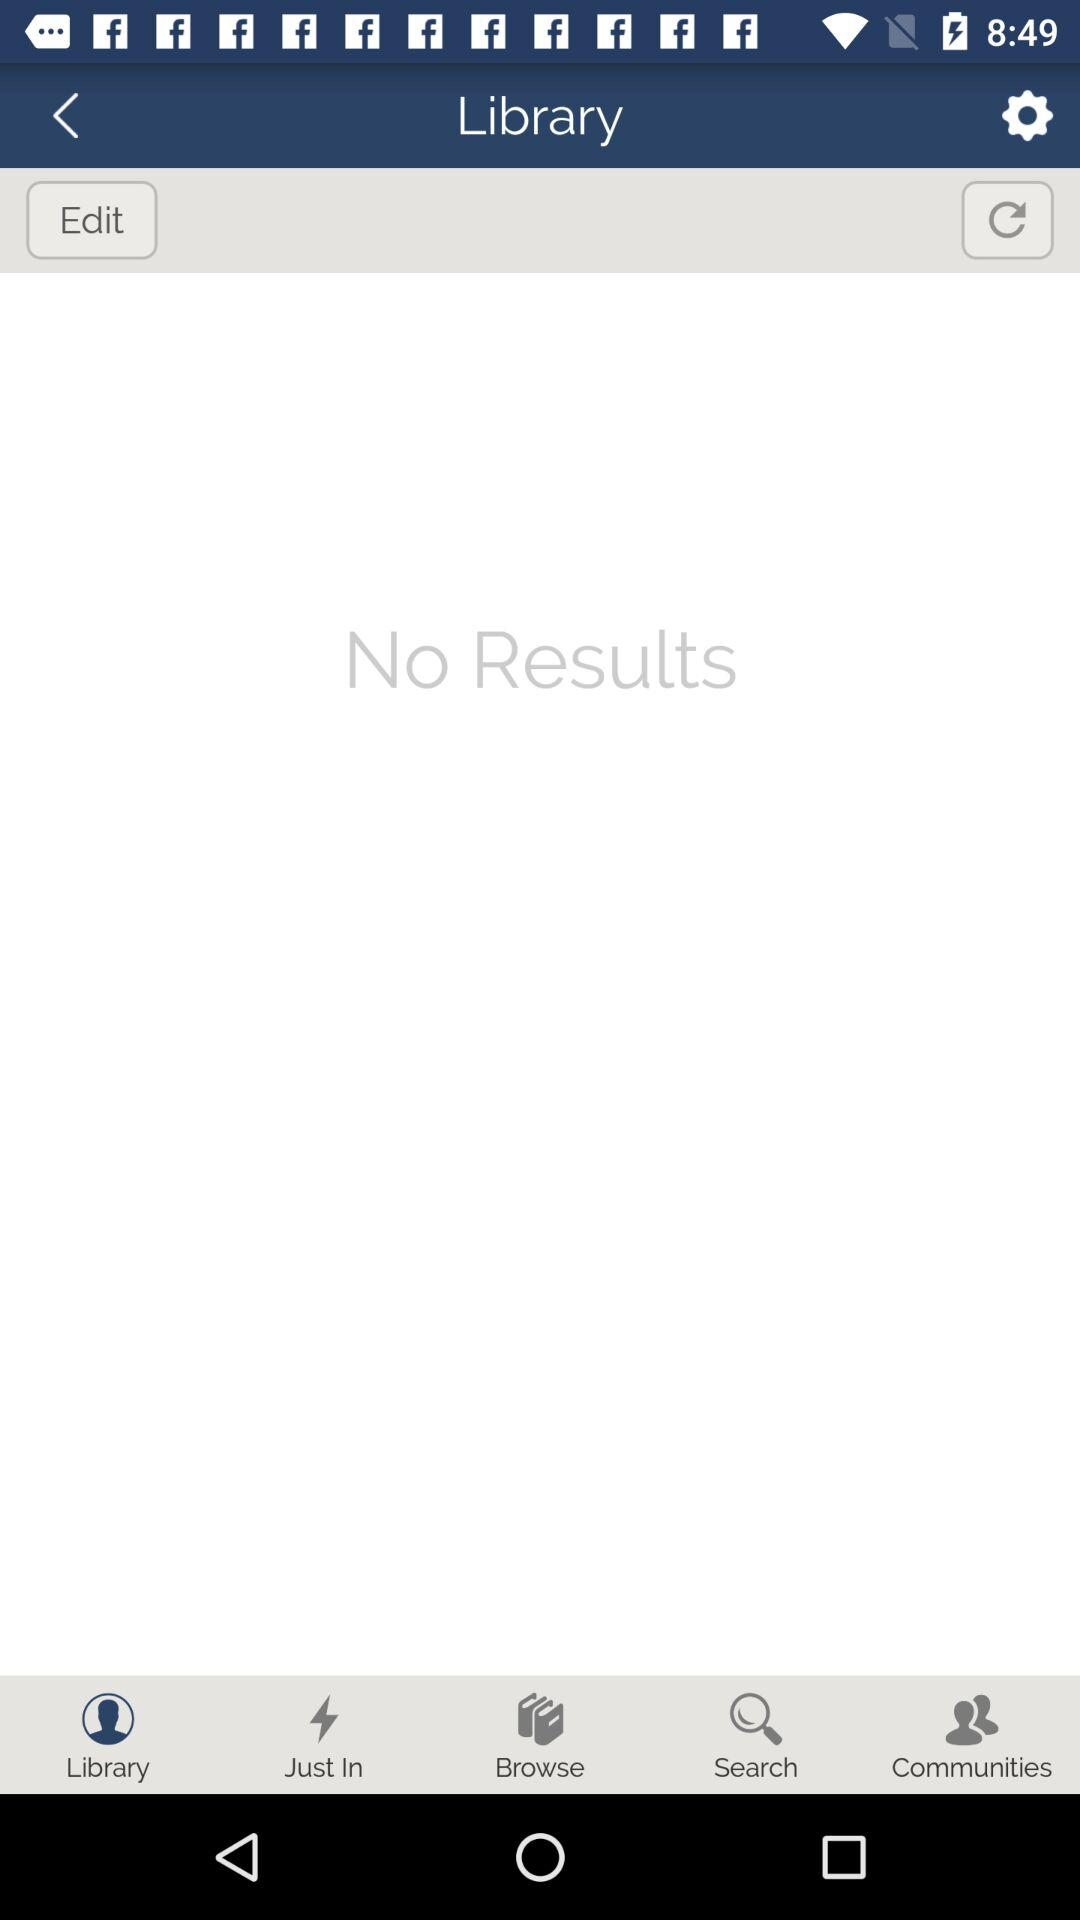Is there any result found? There is no result found. 